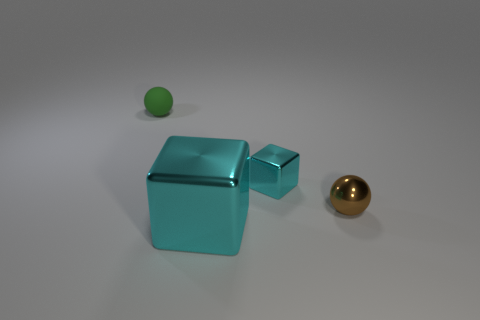Add 4 small green spheres. How many objects exist? 8 Subtract all matte things. Subtract all large cyan metallic things. How many objects are left? 2 Add 2 small cyan things. How many small cyan things are left? 3 Add 2 brown matte cubes. How many brown matte cubes exist? 2 Subtract 0 yellow cubes. How many objects are left? 4 